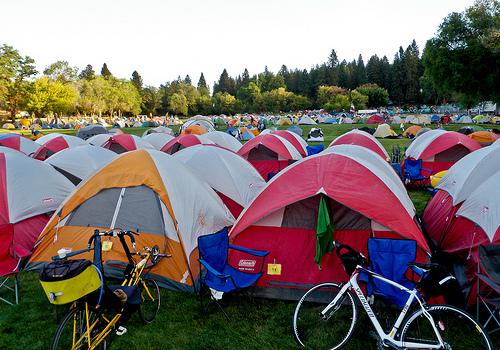Question: where was this picture taken?
Choices:
A. Outside.
B. The woods.
C. At a camping site.
D. Nature.
Answer with the letter. Answer: C Question: how many bikes are at the bottom of the picture?
Choices:
A. 1.
B. 5.
C. 2.
D. 6.
Answer with the letter. Answer: C Question: where do you see the yellow tags in the picture?
Choices:
A. On items.
B. On the ground.
C. Attached to the tents.
D. On the table.
Answer with the letter. Answer: C Question: how many blue chairs are visible in the bottom half of the picture?
Choices:
A. 2.
B. 3.
C. 6.
D. 4.
Answer with the letter. Answer: D Question: where is the chair trimmed in red in the picture?
Choices:
A. The seat of the chair.
B. The back of the chair.
C. Bottom right.
D. The whole chair.
Answer with the letter. Answer: C Question: where are the trees?
Choices:
A. Behind the tents.
B. Outside.
C. In the woods.
D. Under the sun.
Answer with the letter. Answer: A 